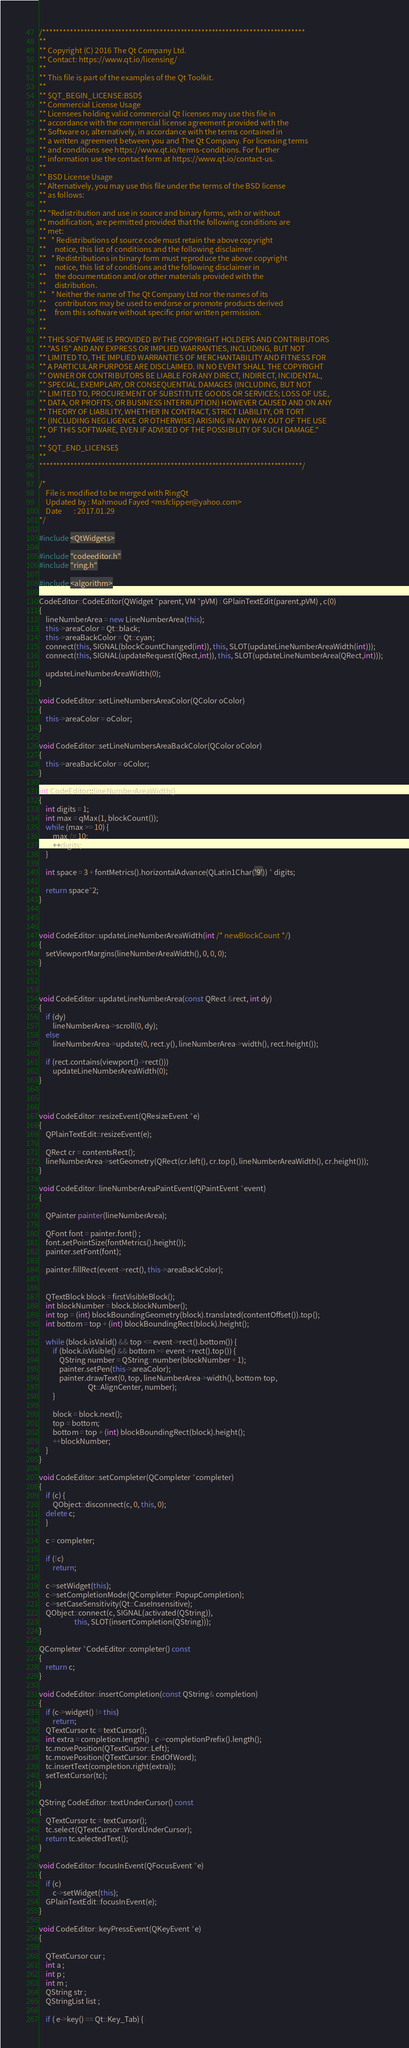<code> <loc_0><loc_0><loc_500><loc_500><_C++_>/****************************************************************************
**
** Copyright (C) 2016 The Qt Company Ltd.
** Contact: https://www.qt.io/licensing/
**
** This file is part of the examples of the Qt Toolkit.
**
** $QT_BEGIN_LICENSE:BSD$
** Commercial License Usage
** Licensees holding valid commercial Qt licenses may use this file in
** accordance with the commercial license agreement provided with the
** Software or, alternatively, in accordance with the terms contained in
** a written agreement between you and The Qt Company. For licensing terms
** and conditions see https://www.qt.io/terms-conditions. For further
** information use the contact form at https://www.qt.io/contact-us.
**
** BSD License Usage
** Alternatively, you may use this file under the terms of the BSD license
** as follows:
**
** "Redistribution and use in source and binary forms, with or without
** modification, are permitted provided that the following conditions are
** met:
**   * Redistributions of source code must retain the above copyright
**     notice, this list of conditions and the following disclaimer.
**   * Redistributions in binary form must reproduce the above copyright
**     notice, this list of conditions and the following disclaimer in
**     the documentation and/or other materials provided with the
**     distribution.
**   * Neither the name of The Qt Company Ltd nor the names of its
**     contributors may be used to endorse or promote products derived
**     from this software without specific prior written permission.
**
**
** THIS SOFTWARE IS PROVIDED BY THE COPYRIGHT HOLDERS AND CONTRIBUTORS
** "AS IS" AND ANY EXPRESS OR IMPLIED WARRANTIES, INCLUDING, BUT NOT
** LIMITED TO, THE IMPLIED WARRANTIES OF MERCHANTABILITY AND FITNESS FOR
** A PARTICULAR PURPOSE ARE DISCLAIMED. IN NO EVENT SHALL THE COPYRIGHT
** OWNER OR CONTRIBUTORS BE LIABLE FOR ANY DIRECT, INDIRECT, INCIDENTAL,
** SPECIAL, EXEMPLARY, OR CONSEQUENTIAL DAMAGES (INCLUDING, BUT NOT
** LIMITED TO, PROCUREMENT OF SUBSTITUTE GOODS OR SERVICES; LOSS OF USE,
** DATA, OR PROFITS; OR BUSINESS INTERRUPTION) HOWEVER CAUSED AND ON ANY
** THEORY OF LIABILITY, WHETHER IN CONTRACT, STRICT LIABILITY, OR TORT
** (INCLUDING NEGLIGENCE OR OTHERWISE) ARISING IN ANY WAY OUT OF THE USE
** OF THIS SOFTWARE, EVEN IF ADVISED OF THE POSSIBILITY OF SUCH DAMAGE."
**
** $QT_END_LICENSE$
**
****************************************************************************/

/*
	File is modified to be merged with RingQt
	Updated by : Mahmoud Fayed <msfclipper@yahoo.com>
	Date	   : 2017.01.29
*/

#include <QtWidgets>

#include "codeeditor.h"
#include "ring.h"

#include <algorithm> 

CodeEditor::CodeEditor(QWidget *parent, VM *pVM) : GPlainTextEdit(parent,pVM) , c(0)
{
    lineNumberArea = new LineNumberArea(this);
    this->areaColor = Qt::black;
    this->areaBackColor = Qt::cyan;
    connect(this, SIGNAL(blockCountChanged(int)), this, SLOT(updateLineNumberAreaWidth(int)));
    connect(this, SIGNAL(updateRequest(QRect,int)), this, SLOT(updateLineNumberArea(QRect,int)));

    updateLineNumberAreaWidth(0);
}

void CodeEditor::setLineNumbersAreaColor(QColor oColor) 
{
    this->areaColor = oColor;
}

void CodeEditor::setLineNumbersAreaBackColor(QColor oColor) 
{
    this->areaBackColor = oColor;
}

int CodeEditor::lineNumberAreaWidth()
{
    int digits = 1;
    int max = qMax(1, blockCount());
    while (max >= 10) {
        max /= 10;
        ++digits;
    }

    int space = 3 + fontMetrics().horizontalAdvance(QLatin1Char('9')) * digits;

    return space*2;
}



void CodeEditor::updateLineNumberAreaWidth(int /* newBlockCount */)
{
    setViewportMargins(lineNumberAreaWidth(), 0, 0, 0);
}



void CodeEditor::updateLineNumberArea(const QRect &rect, int dy)
{
    if (dy)
        lineNumberArea->scroll(0, dy);
    else
        lineNumberArea->update(0, rect.y(), lineNumberArea->width(), rect.height());

    if (rect.contains(viewport()->rect()))
        updateLineNumberAreaWidth(0);
}



void CodeEditor::resizeEvent(QResizeEvent *e)
{
    QPlainTextEdit::resizeEvent(e);

    QRect cr = contentsRect();
    lineNumberArea->setGeometry(QRect(cr.left(), cr.top(), lineNumberAreaWidth(), cr.height()));
}

void CodeEditor::lineNumberAreaPaintEvent(QPaintEvent *event)
{

    QPainter painter(lineNumberArea);

    QFont font = painter.font() ;
    font.setPointSize(fontMetrics().height());
    painter.setFont(font);

    painter.fillRect(event->rect(), this->areaBackColor);


    QTextBlock block = firstVisibleBlock();
    int blockNumber = block.blockNumber();
    int top = (int) blockBoundingGeometry(block).translated(contentOffset()).top();
    int bottom = top + (int) blockBoundingRect(block).height();

    while (block.isValid() && top <= event->rect().bottom()) {
        if (block.isVisible() && bottom >= event->rect().top()) {
            QString number = QString::number(blockNumber + 1);
            painter.setPen(this->areaColor);
            painter.drawText(0, top, lineNumberArea->width(), bottom-top,
                             Qt::AlignCenter, number);
        }

        block = block.next();
        top = bottom;
        bottom = top + (int) blockBoundingRect(block).height();
        ++blockNumber;
    }
}

void CodeEditor::setCompleter(QCompleter *completer)
{
    if (c) {
        QObject::disconnect(c, 0, this, 0);
	delete c;
    }

    c = completer;

    if (!c)
        return;

    c->setWidget(this);
    c->setCompletionMode(QCompleter::PopupCompletion);
    c->setCaseSensitivity(Qt::CaseInsensitive);
    QObject::connect(c, SIGNAL(activated(QString)),
                     this, SLOT(insertCompletion(QString)));
}

QCompleter *CodeEditor::completer() const
{
    return c;
}

void CodeEditor::insertCompletion(const QString& completion)
{
    if (c->widget() != this)
        return;
    QTextCursor tc = textCursor();
    int extra = completion.length() - c->completionPrefix().length();
    tc.movePosition(QTextCursor::Left);
    tc.movePosition(QTextCursor::EndOfWord);
    tc.insertText(completion.right(extra));
    setTextCursor(tc);
}

QString CodeEditor::textUnderCursor() const
{
    QTextCursor tc = textCursor();
    tc.select(QTextCursor::WordUnderCursor);
    return tc.selectedText();
}

void CodeEditor::focusInEvent(QFocusEvent *e)
{
    if (c)
        c->setWidget(this);
    GPlainTextEdit::focusInEvent(e);
}

void CodeEditor::keyPressEvent(QKeyEvent *e)
{

	QTextCursor cur ;
	int a ;
	int p ;
	int m ;
	QString str ;
	QStringList list ;
	
	if ( e->key() == Qt::Key_Tab) {</code> 